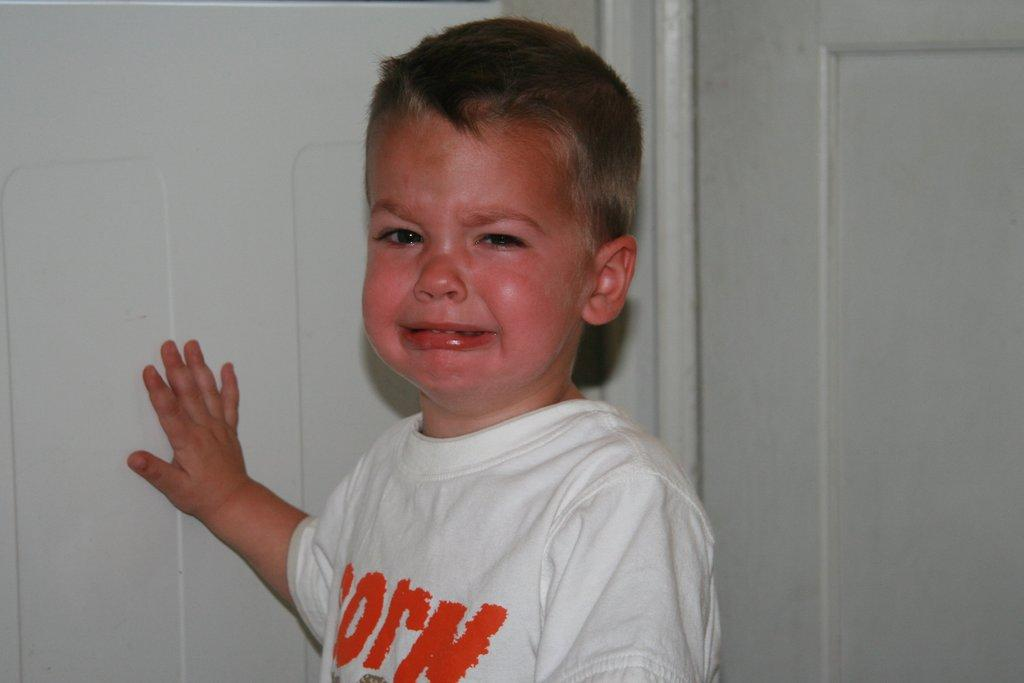Who is present in the image? There is a boy in the image. What is the boy doing in the image? The boy is crying in the image. What can be seen in the background of the image? There is a wall in the background of the image. What type of shoe is the boy wearing in the image? There is no information about the boy's shoes in the image, so we cannot determine what type of shoe he is wearing. 